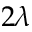<formula> <loc_0><loc_0><loc_500><loc_500>2 \lambda</formula> 